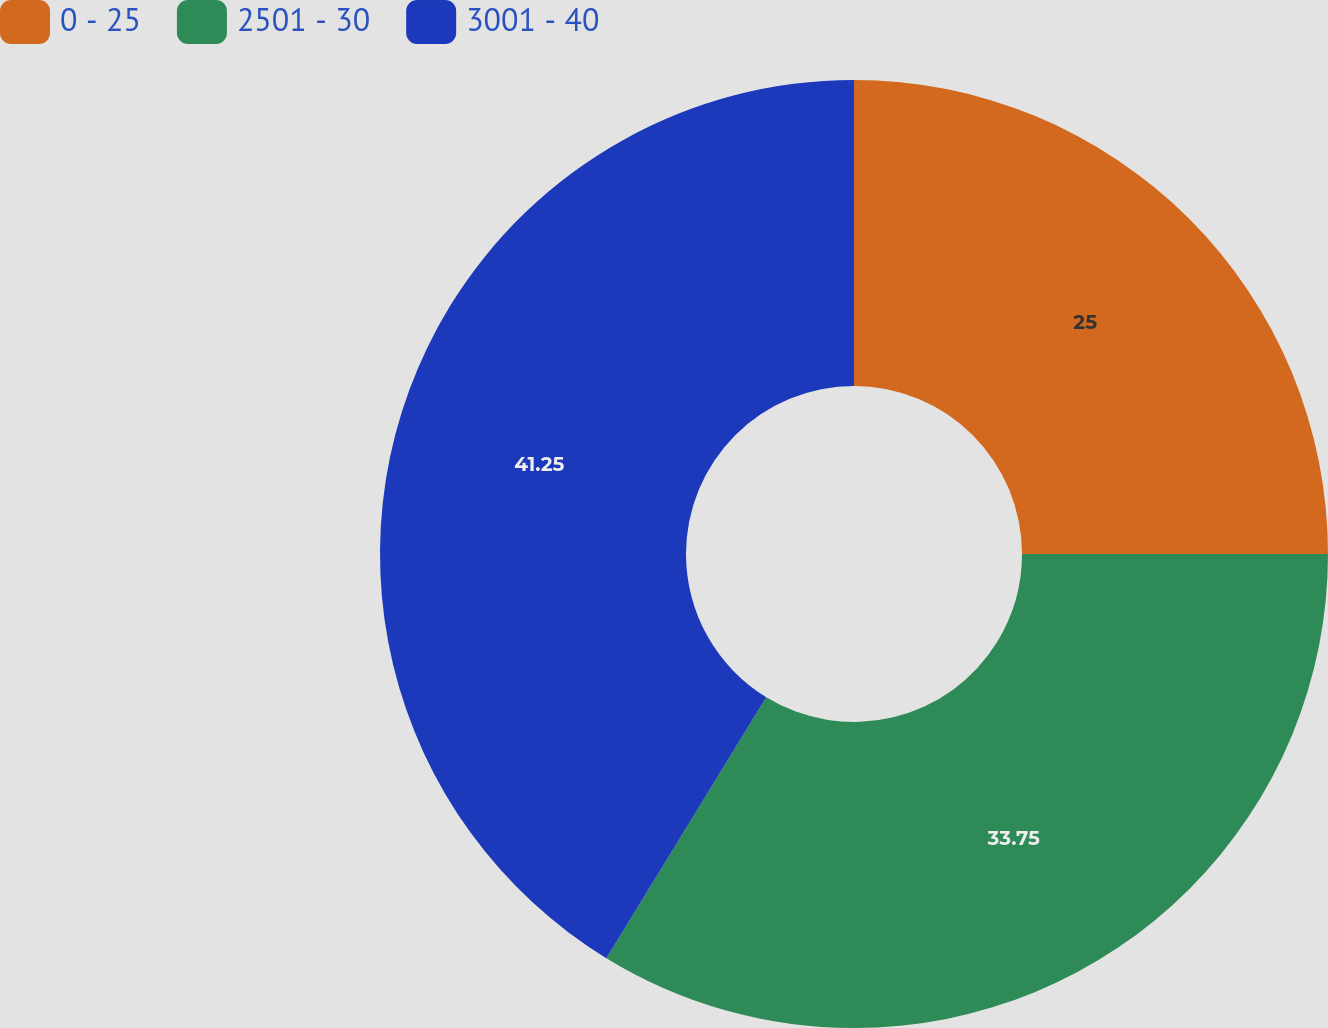Convert chart. <chart><loc_0><loc_0><loc_500><loc_500><pie_chart><fcel>0 - 25<fcel>2501 - 30<fcel>3001 - 40<nl><fcel>25.0%<fcel>33.75%<fcel>41.25%<nl></chart> 